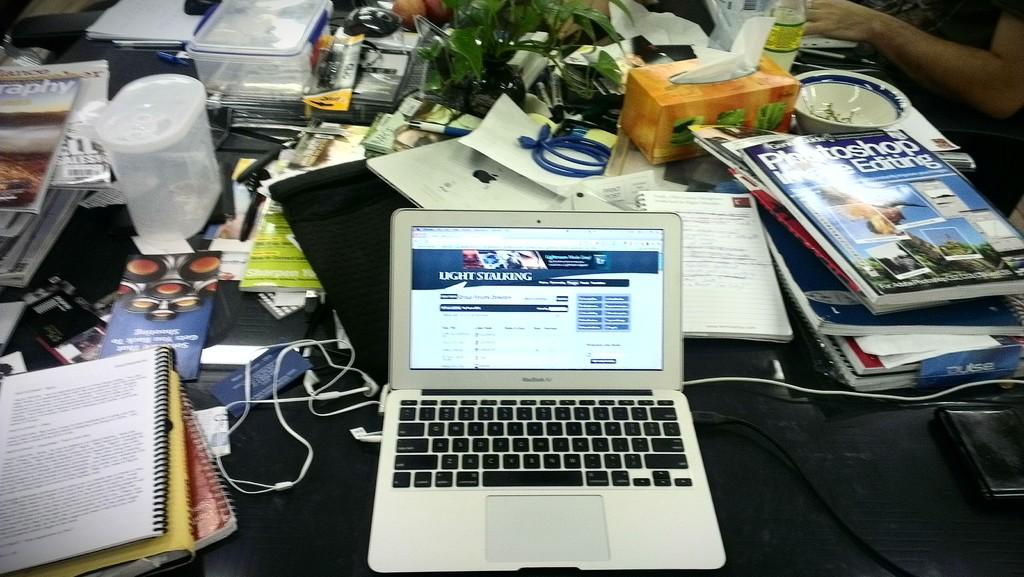<image>
Offer a succinct explanation of the picture presented. A laptop on a cluttered desk is opened to the Light Stalking web page. 